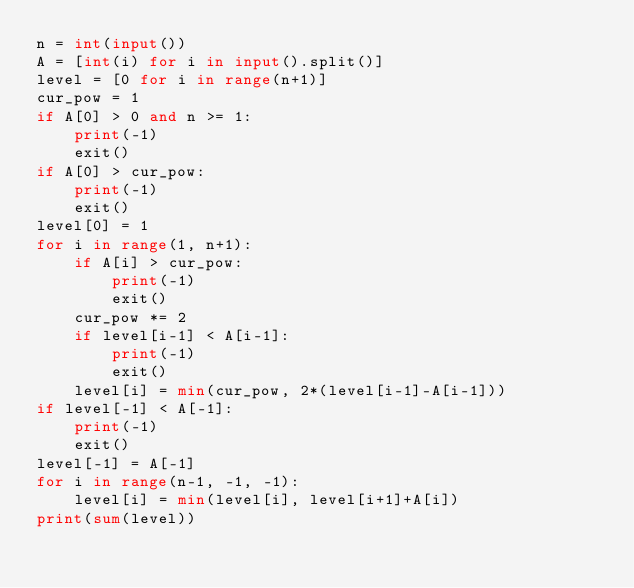<code> <loc_0><loc_0><loc_500><loc_500><_Python_>n = int(input())
A = [int(i) for i in input().split()]
level = [0 for i in range(n+1)]
cur_pow = 1
if A[0] > 0 and n >= 1:
    print(-1)
    exit()
if A[0] > cur_pow:
    print(-1)
    exit()
level[0] = 1
for i in range(1, n+1):
    if A[i] > cur_pow:
        print(-1)
        exit()
    cur_pow *= 2
    if level[i-1] < A[i-1]:
        print(-1)
        exit()
    level[i] = min(cur_pow, 2*(level[i-1]-A[i-1]))
if level[-1] < A[-1]:
    print(-1)
    exit()
level[-1] = A[-1]
for i in range(n-1, -1, -1):
    level[i] = min(level[i], level[i+1]+A[i])
print(sum(level))</code> 